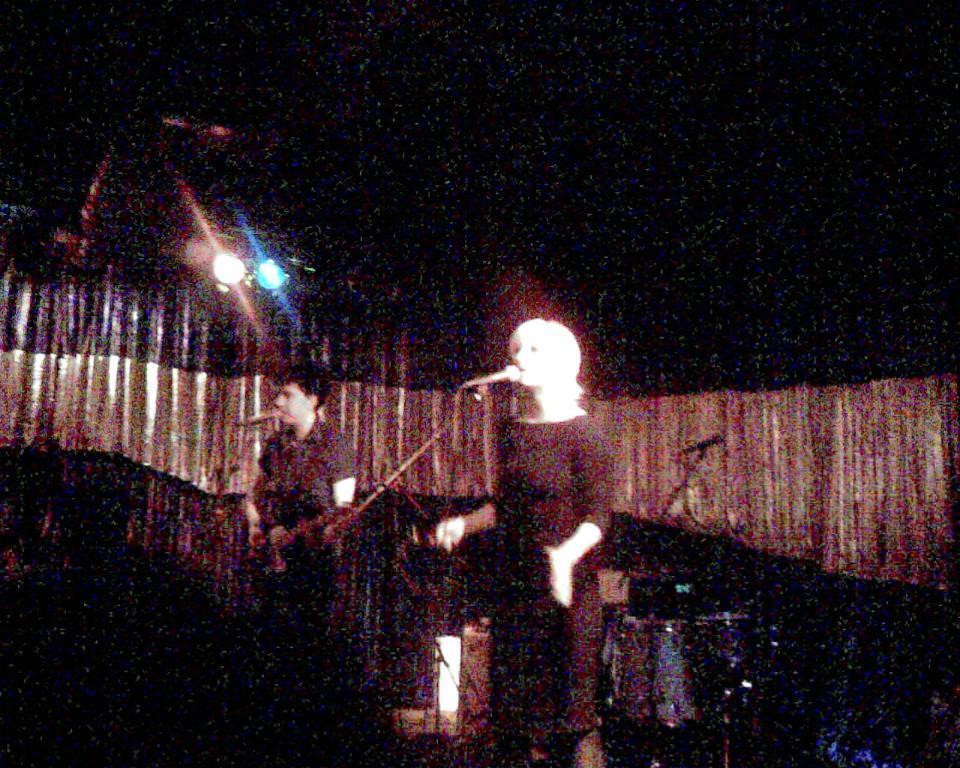In one or two sentences, can you explain what this image depicts? In this image two persons are singing a song. In front of them there are mike's. At the back side there are curtains, lights, drums and few other objects. 